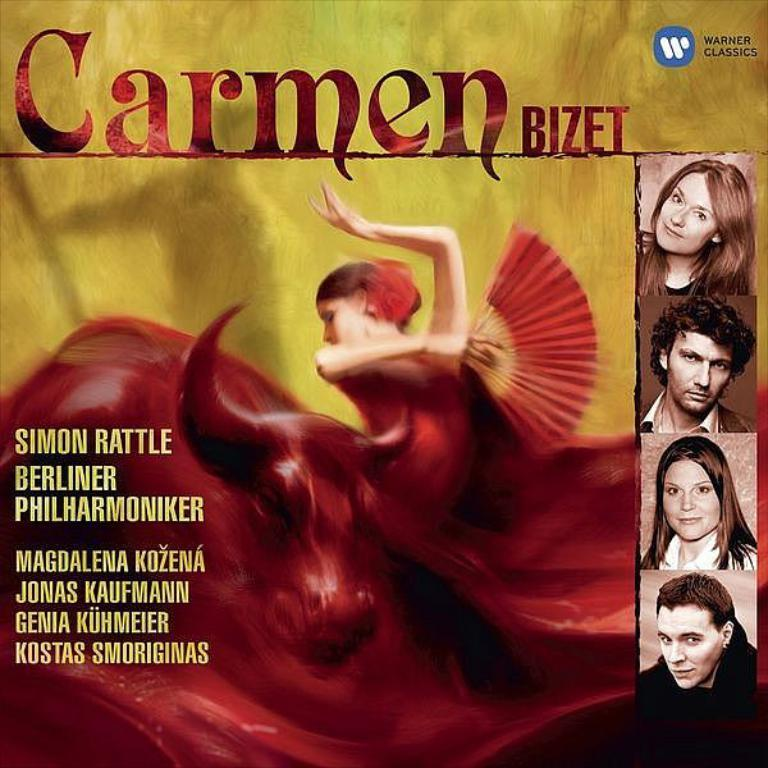What is featured on the poster in the image? There is a poster with text in the image. What else can be seen in the image besides the poster? There are images of persons and an edited image of a lady holding something in her hand. Can you describe the edited image of the lady? The edited image of the lady shows her holding something in her hand. What type of living creature is visible in the image? There is an animal visible in the image. What type of kite is being flown by the person in the image? There is no kite visible in the image; it only features a poster, images of persons, an edited image of a lady, and an animal. 